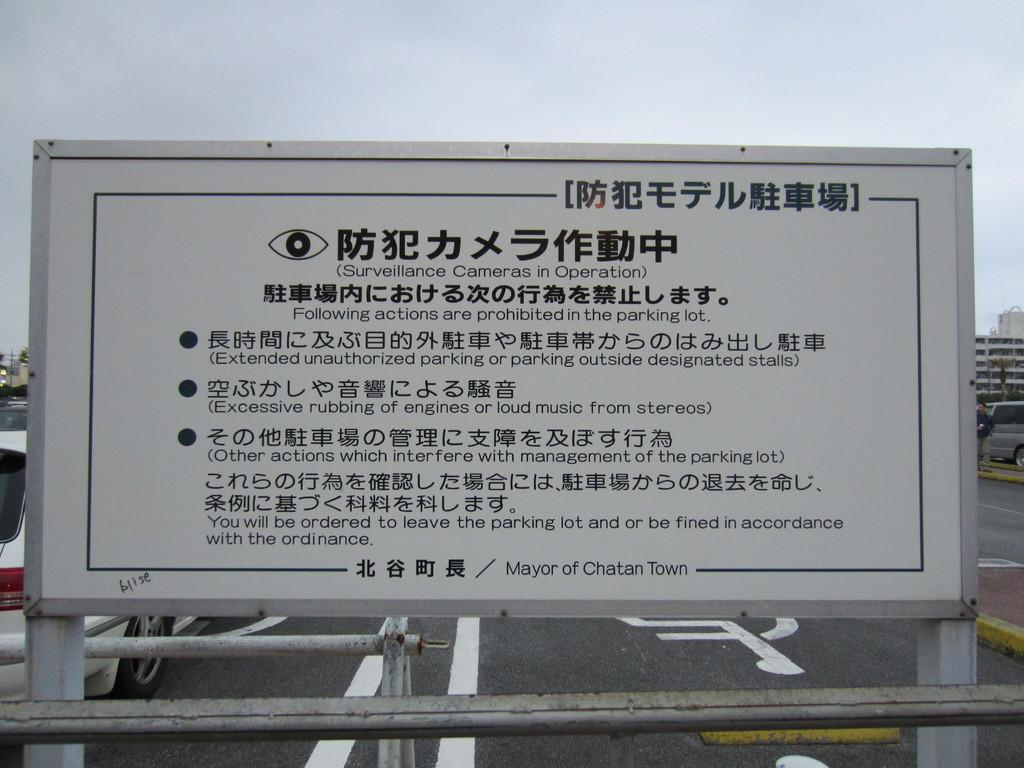What is written or displayed on the board in the image? There is a board with text in the image, but we cannot determine the exact content from the image alone. How many cars are visible in the image? There are two cars visible in the image. What type of structures can be seen in the background of the image? There are buildings visible in the image. What is the weather like in the image? The sky is cloudy in the image, suggesting a partly cloudy or overcast day. How many babies are swimming in the image? There are no babies or swimming activities present in the image. Can you describe the kick of the person in the image? There is no person kicking in the image; the human is standing still. 